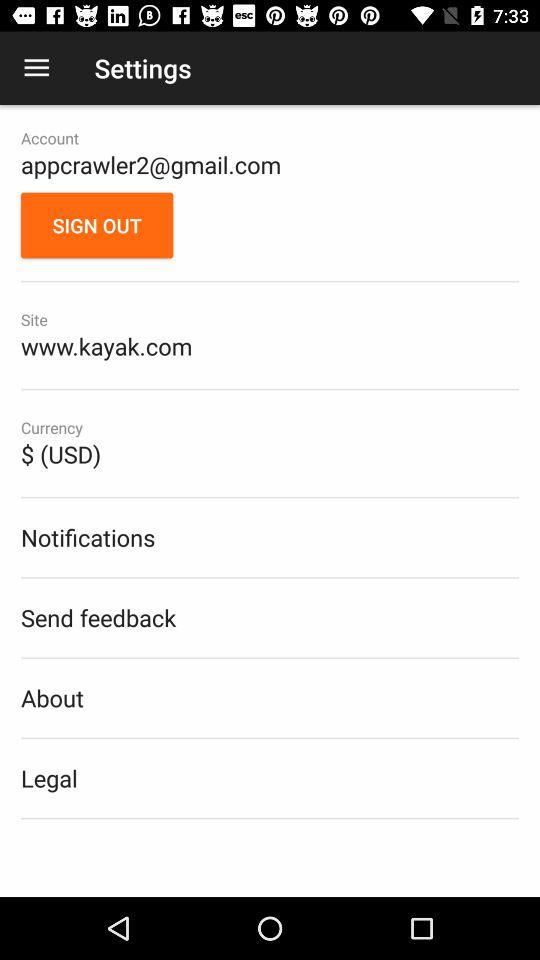What is the given site? The given site is "www.kayak.com". 